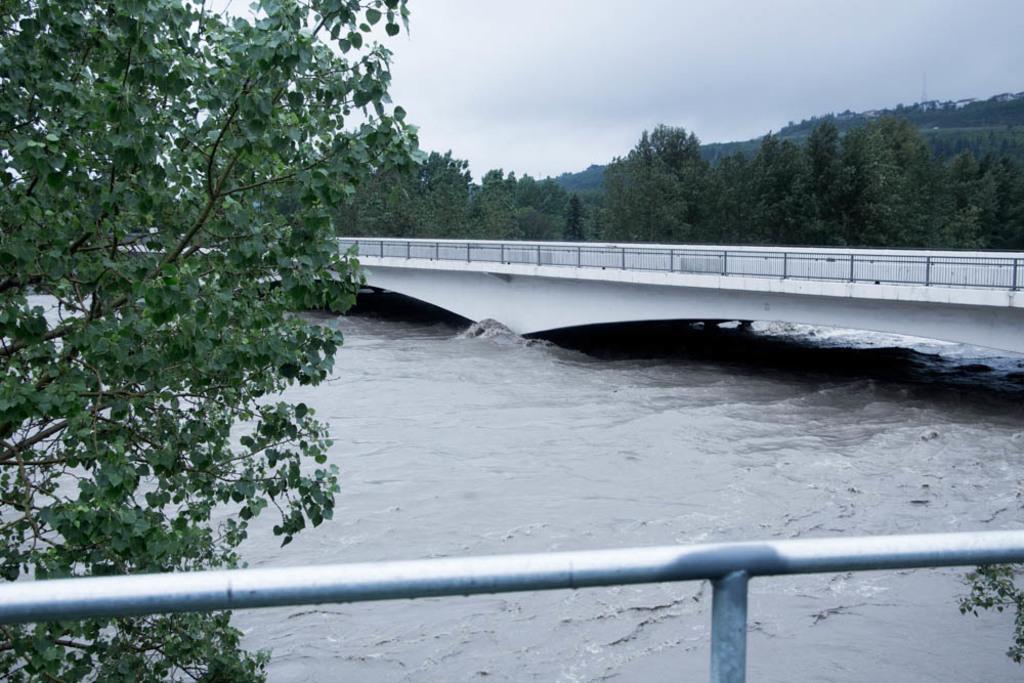In one or two sentences, can you explain what this image depicts? In the foreground of this image, there is a rod, tree and the water. In the background, there is a bridge, trees and the cloud. 